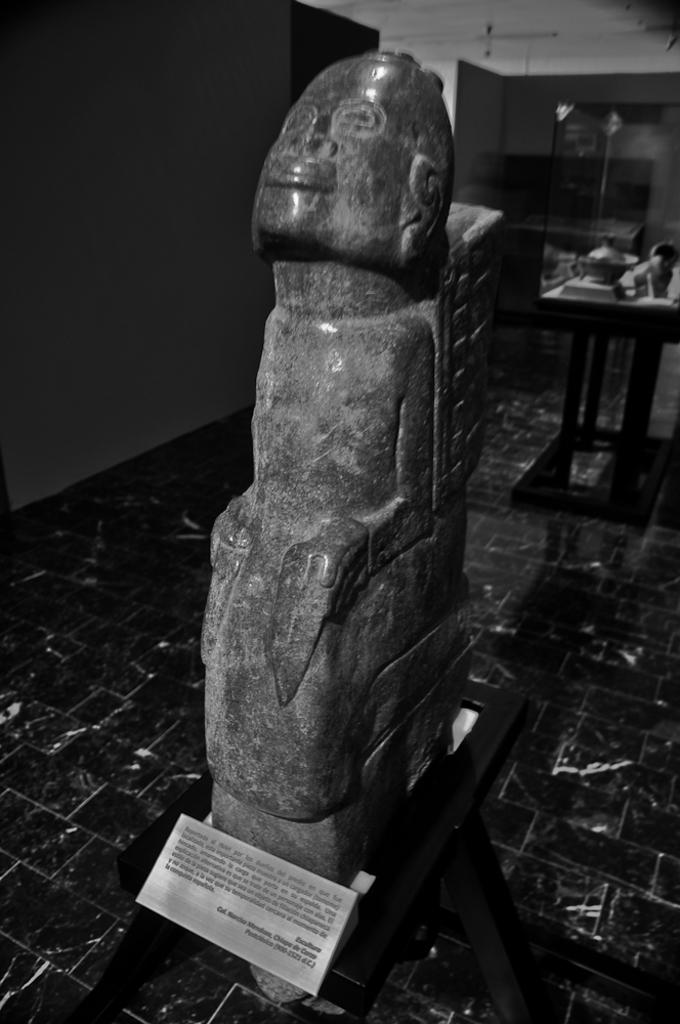What is the main subject in the foreground of the image? There is a sculpture in the foreground of the image. Can you describe any other objects or structures in the image? There is a table in the image. What type of caption is written on the sculpture in the image? There is no caption written on the sculpture in the image. Can you see any harbors or boats in the image? The provided facts do not mention any harbors or boats, so we cannot determine their presence in the image. 